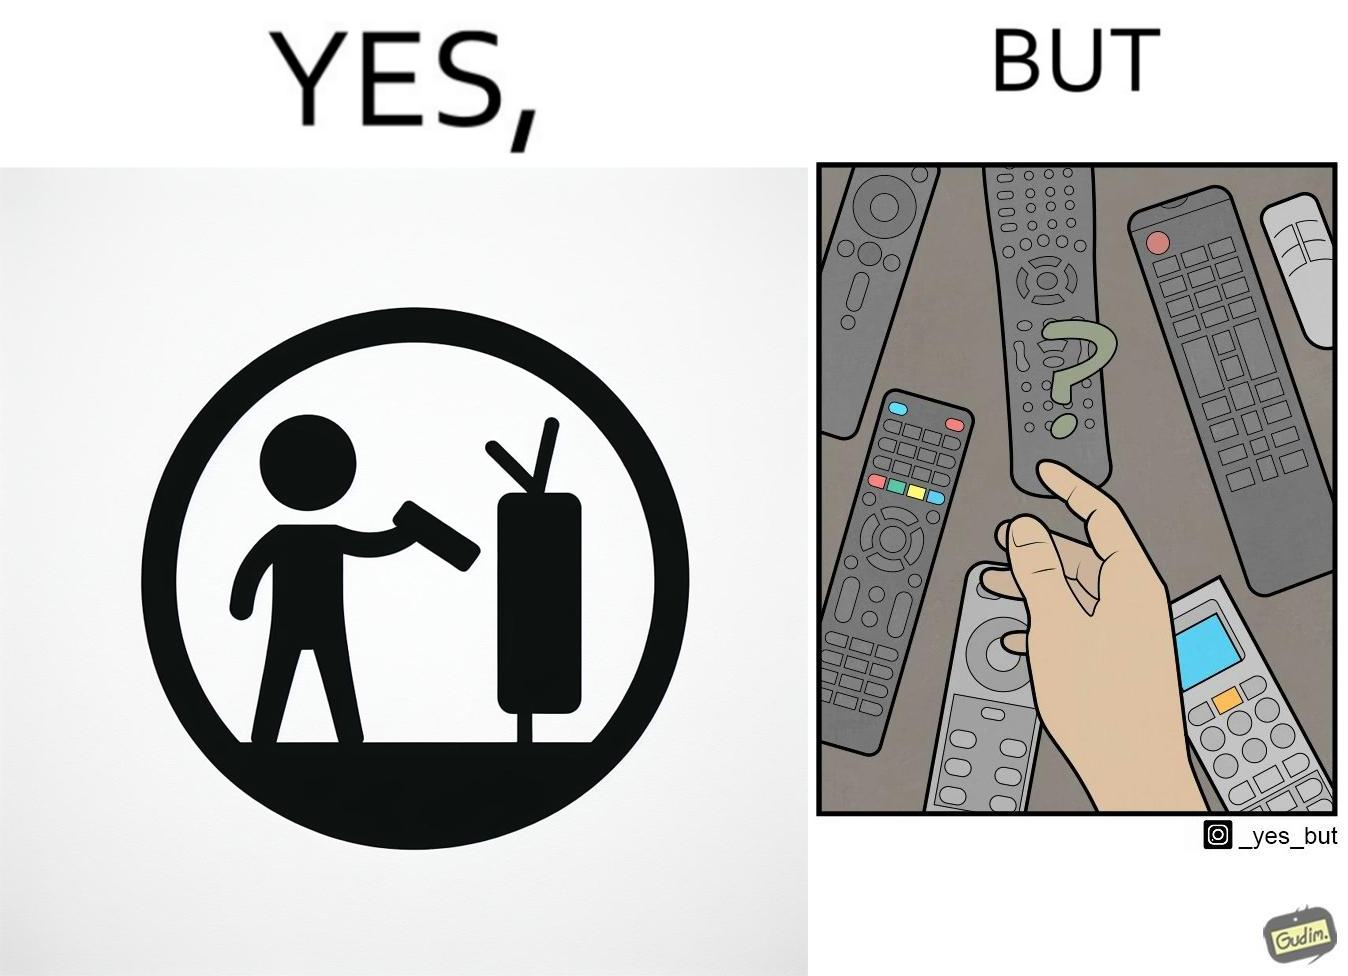Is there satirical content in this image? Yes, this image is satirical. 